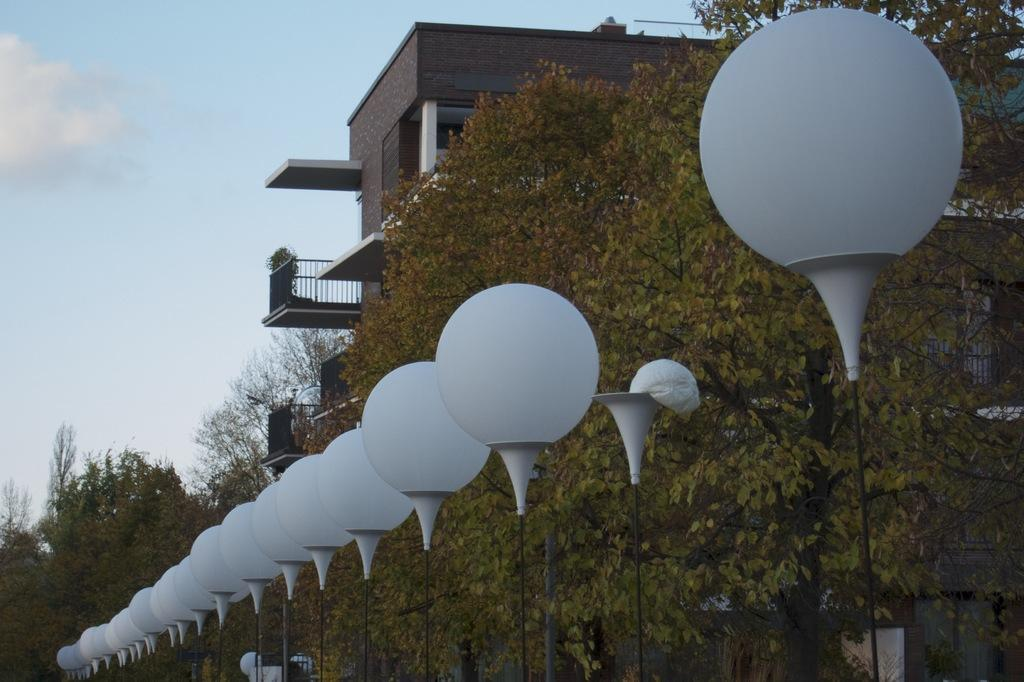What can be seen at the front of the image? There are lights in the front of the image. What is visible in the background of the image? There are trees and a building in the background of the image. What is the condition of the sky in the image? The sky is cloudy in the image. How many women are walking with brass instruments in the image? There are no women or brass instruments present in the image. 